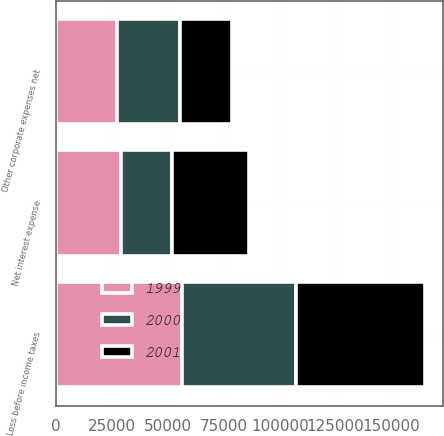Convert chart. <chart><loc_0><loc_0><loc_500><loc_500><stacked_bar_chart><ecel><fcel>Net interest expense<fcel>Other corporate expenses net<fcel>Loss before income taxes<nl><fcel>2001<fcel>34261<fcel>23191<fcel>57452<nl><fcel>1999<fcel>28987<fcel>27309<fcel>56296<nl><fcel>2000<fcel>22824<fcel>28160<fcel>50984<nl></chart> 